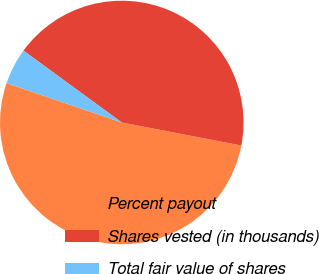Convert chart to OTSL. <chart><loc_0><loc_0><loc_500><loc_500><pie_chart><fcel>Percent payout<fcel>Shares vested (in thousands)<fcel>Total fair value of shares<nl><fcel>52.21%<fcel>42.99%<fcel>4.8%<nl></chart> 